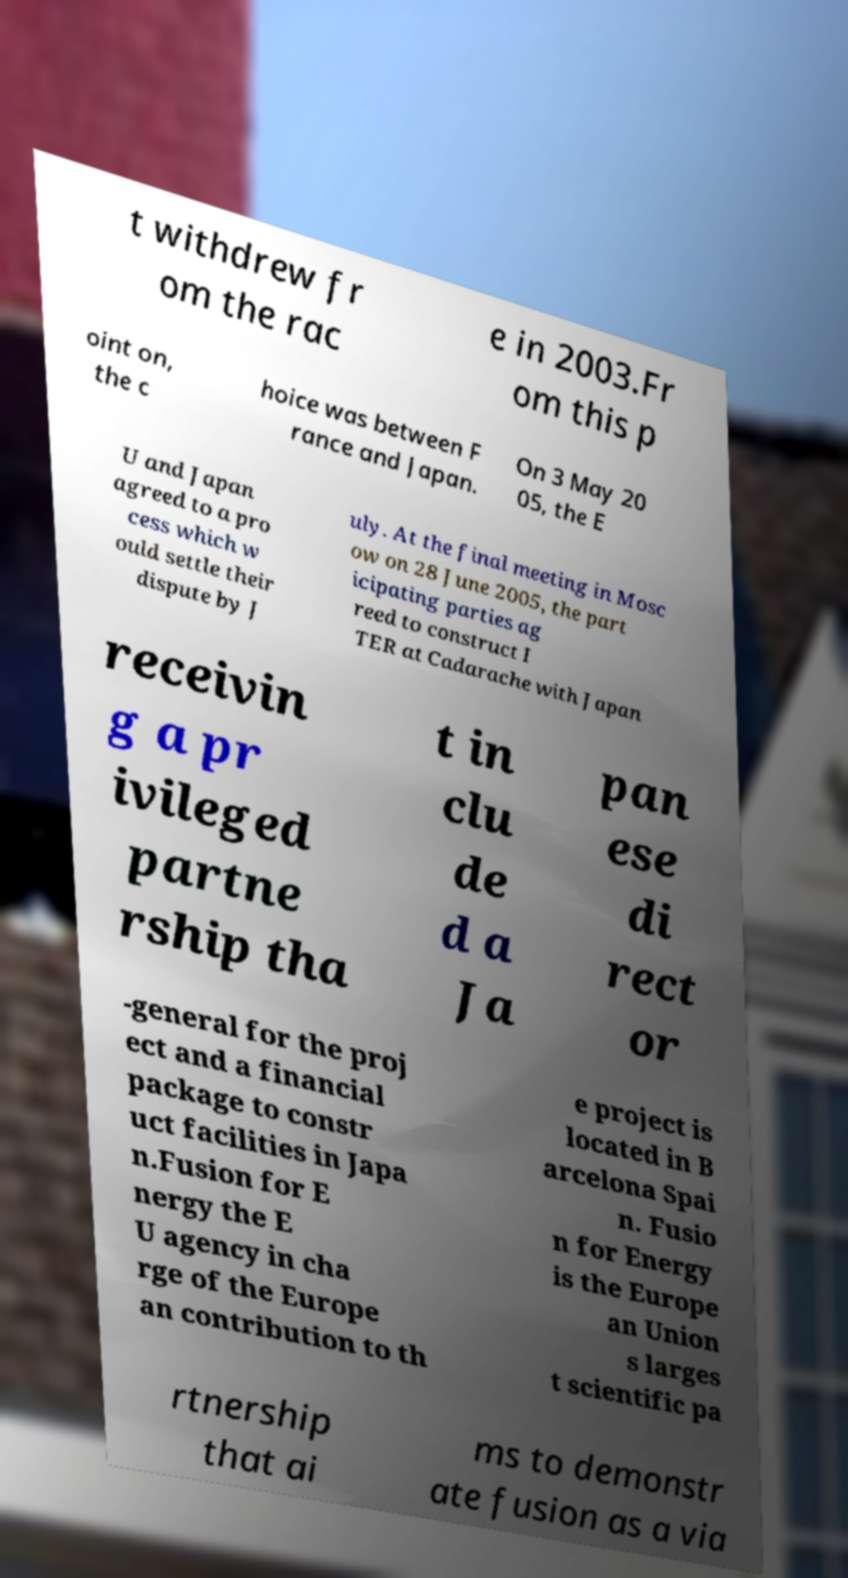Could you assist in decoding the text presented in this image and type it out clearly? t withdrew fr om the rac e in 2003.Fr om this p oint on, the c hoice was between F rance and Japan. On 3 May 20 05, the E U and Japan agreed to a pro cess which w ould settle their dispute by J uly. At the final meeting in Mosc ow on 28 June 2005, the part icipating parties ag reed to construct I TER at Cadarache with Japan receivin g a pr ivileged partne rship tha t in clu de d a Ja pan ese di rect or -general for the proj ect and a financial package to constr uct facilities in Japa n.Fusion for E nergy the E U agency in cha rge of the Europe an contribution to th e project is located in B arcelona Spai n. Fusio n for Energy is the Europe an Union s larges t scientific pa rtnership that ai ms to demonstr ate fusion as a via 